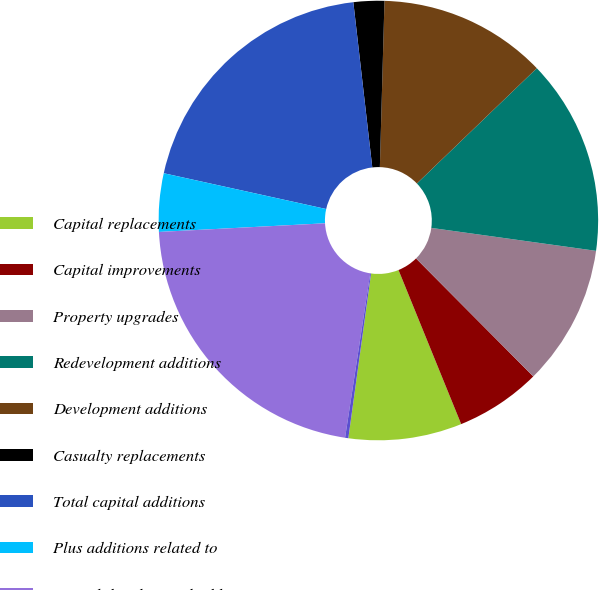<chart> <loc_0><loc_0><loc_500><loc_500><pie_chart><fcel>Capital replacements<fcel>Capital improvements<fcel>Property upgrades<fcel>Redevelopment additions<fcel>Development additions<fcel>Casualty replacements<fcel>Total capital additions<fcel>Plus additions related to<fcel>Consolidated capital additions<fcel>Plus net change in accrued<nl><fcel>8.33%<fcel>6.3%<fcel>10.35%<fcel>14.39%<fcel>12.37%<fcel>2.26%<fcel>19.73%<fcel>4.28%<fcel>21.75%<fcel>0.24%<nl></chart> 